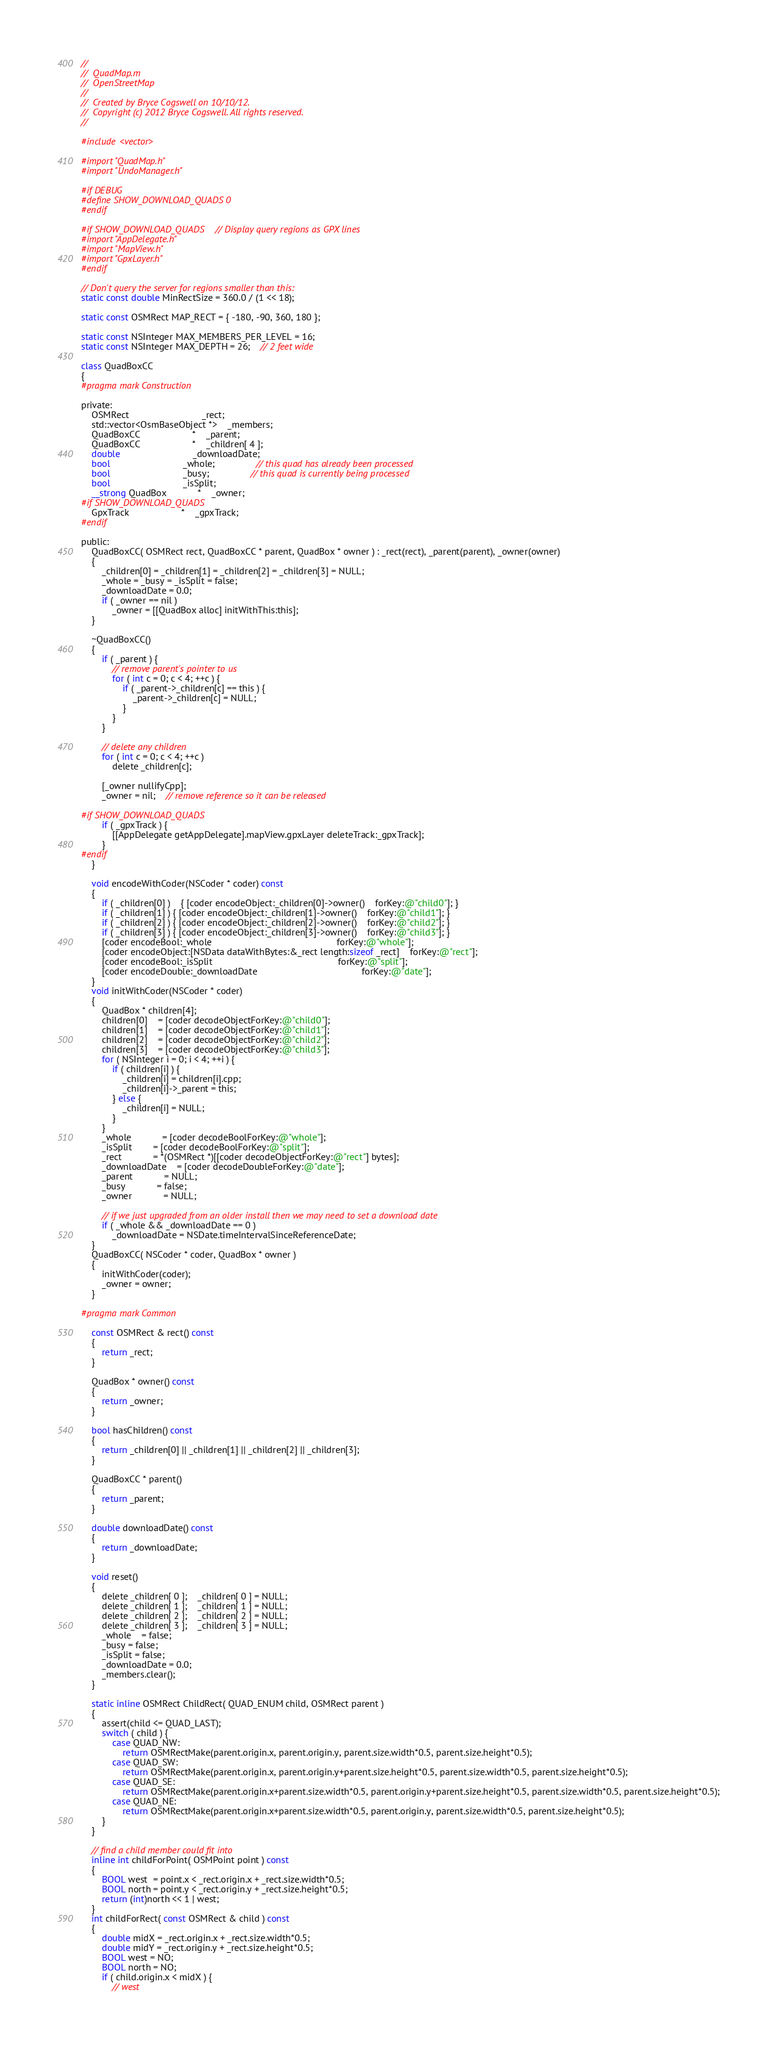<code> <loc_0><loc_0><loc_500><loc_500><_ObjectiveC_>//
//  QuadMap.m
//  OpenStreetMap
//
//  Created by Bryce Cogswell on 10/10/12.
//  Copyright (c) 2012 Bryce Cogswell. All rights reserved.
//

#include <vector>

#import "QuadMap.h"
#import "UndoManager.h"

#if DEBUG
#define SHOW_DOWNLOAD_QUADS 0
#endif

#if SHOW_DOWNLOAD_QUADS	// Display query regions as GPX lines
#import "AppDelegate.h"
#import "MapView.h"
#import "GpxLayer.h"
#endif

// Don't query the server for regions smaller than this:
static const double MinRectSize = 360.0 / (1 << 18);

static const OSMRect MAP_RECT = { -180, -90, 360, 180 };

static const NSInteger MAX_MEMBERS_PER_LEVEL = 16;
static const NSInteger MAX_DEPTH = 26;	// 2 feet wide

class QuadBoxCC
{
#pragma mark Construction

private:
	OSMRect							_rect;
	std::vector<OsmBaseObject *>	_members;
	QuadBoxCC					*	_parent;
	QuadBoxCC					*	_children[ 4 ];
	double							_downloadDate;
	bool							_whole;				// this quad has already been processed
	bool							_busy;				// this quad is currently being processed
	bool							_isSplit;
	__strong QuadBox			*	_owner;
#if SHOW_DOWNLOAD_QUADS
	GpxTrack					*	_gpxTrack;
#endif

public:
	QuadBoxCC( OSMRect rect, QuadBoxCC * parent, QuadBox * owner ) : _rect(rect), _parent(parent), _owner(owner)
	{
		_children[0] = _children[1] = _children[2] = _children[3] = NULL;
		_whole = _busy = _isSplit = false;
		_downloadDate = 0.0;
		if ( _owner == nil )
			_owner = [[QuadBox alloc] initWithThis:this];
	}

	~QuadBoxCC()
	{
		if ( _parent ) {
			// remove parent's pointer to us
			for ( int c = 0; c < 4; ++c ) {
				if ( _parent->_children[c] == this ) {
					_parent->_children[c] = NULL;
				}
			}
		}

		// delete any children
		for ( int c = 0; c < 4; ++c )
			delete _children[c];
		
		[_owner nullifyCpp];
		_owner = nil;	// remove reference so it can be released

#if SHOW_DOWNLOAD_QUADS
		if ( _gpxTrack ) {
			[[AppDelegate getAppDelegate].mapView.gpxLayer deleteTrack:_gpxTrack];
		}
#endif
	}

	void encodeWithCoder(NSCoder * coder) const
	{
		if ( _children[0] )	{ [coder encodeObject:_children[0]->owner()	forKey:@"child0"]; }
		if ( _children[1] ) { [coder encodeObject:_children[1]->owner()	forKey:@"child1"]; }
		if ( _children[2] ) { [coder encodeObject:_children[2]->owner()	forKey:@"child2"]; }
		if ( _children[3] ) { [coder encodeObject:_children[3]->owner()	forKey:@"child3"]; }
		[coder encodeBool:_whole												forKey:@"whole"];
		[coder encodeObject:[NSData dataWithBytes:&_rect length:sizeof _rect]	forKey:@"rect"];
		[coder encodeBool:_isSplit												forKey:@"split"];
		[coder encodeDouble:_downloadDate 										forKey:@"date"];
	}
	void initWithCoder(NSCoder * coder)
	{
		QuadBox * children[4];
		children[0]	= [coder decodeObjectForKey:@"child0"];
		children[1]	= [coder decodeObjectForKey:@"child1"];
		children[2]	= [coder decodeObjectForKey:@"child2"];
		children[3]	= [coder decodeObjectForKey:@"child3"];
		for ( NSInteger i = 0; i < 4; ++i ) {
			if ( children[i] ) {
				_children[i] = children[i].cpp;
				_children[i]->_parent = this;
			} else {
				_children[i] = NULL;
			}
		}
		_whole			= [coder decodeBoolForKey:@"whole"];
		_isSplit		= [coder decodeBoolForKey:@"split"];
		_rect			= *(OSMRect *)[[coder decodeObjectForKey:@"rect"] bytes];
		_downloadDate	= [coder decodeDoubleForKey:@"date"];
		_parent			= NULL;
		_busy			= false;
		_owner			= NULL;

		// if we just upgraded from an older install then we may need to set a download date
		if ( _whole && _downloadDate == 0 )
			_downloadDate = NSDate.timeIntervalSinceReferenceDate;
	}
	QuadBoxCC( NSCoder * coder, QuadBox * owner )
	{
		initWithCoder(coder);
		_owner = owner;
	}

#pragma mark Common

	const OSMRect & rect() const
	{
		return _rect;
	}

	QuadBox * owner() const
	{
		return _owner;
	}

	bool hasChildren() const
	{
		return _children[0] || _children[1] || _children[2] || _children[3];
	}

	QuadBoxCC * parent()
	{
		return _parent;
	}

	double downloadDate() const
	{
		return _downloadDate;
	}

	void reset()
	{
		delete _children[ 0 ];	_children[ 0 ] = NULL;
		delete _children[ 1 ];	_children[ 1 ] = NULL;
		delete _children[ 2 ];	_children[ 2 ] = NULL;
		delete _children[ 3 ];	_children[ 3 ] = NULL;
		_whole	= false;
		_busy = false;
		_isSplit = false;
		_downloadDate = 0.0;
		_members.clear();
	}

	static inline OSMRect ChildRect( QUAD_ENUM child, OSMRect parent )
	{
		assert(child <= QUAD_LAST);
		switch ( child ) {
			case QUAD_NW:
				return OSMRectMake(parent.origin.x, parent.origin.y, parent.size.width*0.5, parent.size.height*0.5);
			case QUAD_SW:
				return OSMRectMake(parent.origin.x, parent.origin.y+parent.size.height*0.5, parent.size.width*0.5, parent.size.height*0.5);
			case QUAD_SE:
				return OSMRectMake(parent.origin.x+parent.size.width*0.5, parent.origin.y+parent.size.height*0.5, parent.size.width*0.5, parent.size.height*0.5);
			case QUAD_NE:
				return OSMRectMake(parent.origin.x+parent.size.width*0.5, parent.origin.y, parent.size.width*0.5, parent.size.height*0.5);
		}
	}

	// find a child member could fit into
	inline int childForPoint( OSMPoint point ) const
	{
		BOOL west  = point.x < _rect.origin.x + _rect.size.width*0.5;
		BOOL north = point.y < _rect.origin.y + _rect.size.height*0.5;
		return (int)north << 1 | west;
	}
	int childForRect( const OSMRect & child ) const
	{
		double midX = _rect.origin.x + _rect.size.width*0.5;
		double midY = _rect.origin.y + _rect.size.height*0.5;
		BOOL west = NO;
		BOOL north = NO;
		if ( child.origin.x < midX ) {
			// west</code> 